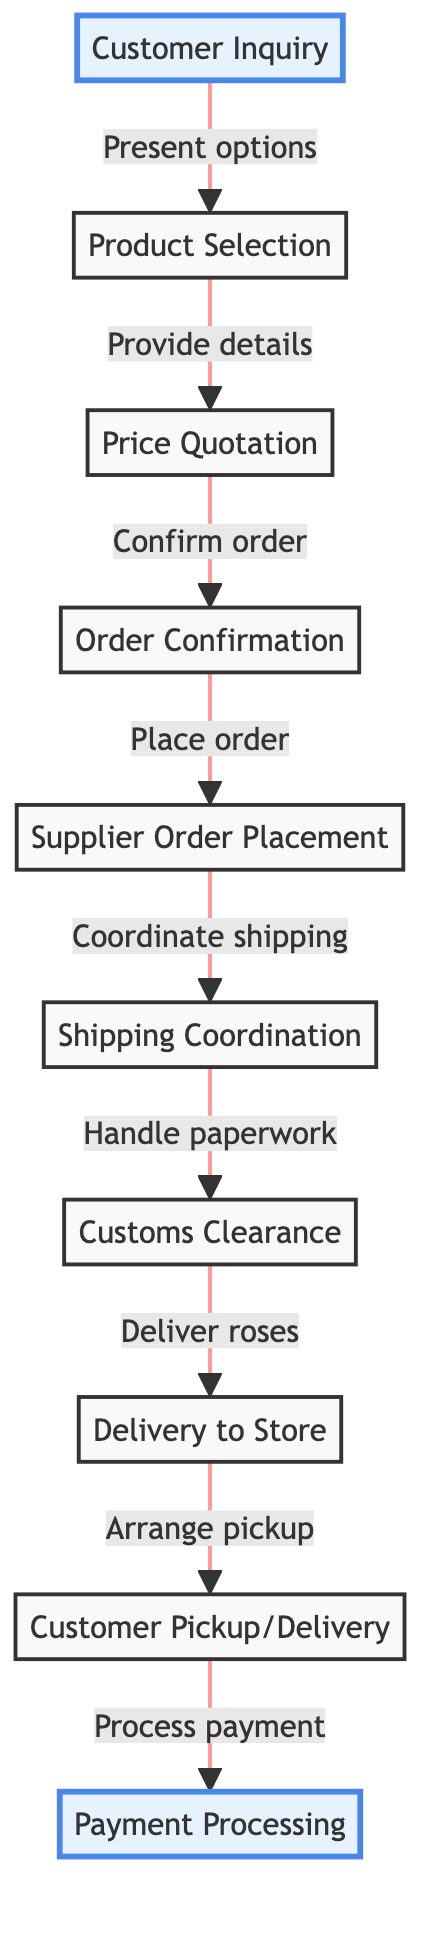What is the first step in the ordering process? The first step in the flow chart is "Customer Inquiry." This node is the starting point of the entire process, indicating that the customer contacts the florist to inquire about rose varieties and prices.
Answer: Customer Inquiry How many steps are there in the ordering process? By counting the nodes in the flow chart, there are a total of 10 steps, from "Customer Inquiry" to "Payment Processing." Each step represents a specific part of the process from start to finish.
Answer: 10 What action follows "Price Quotation"? The action that follows "Price Quotation" in the flow chart is "Order Confirmation." This indicates that after the florist provides pricing details, the customer confirms the order and provides delivery details.
Answer: Order Confirmation Which step involves handling paperwork and permits? The step involving handling paperwork and permits is "Customs Clearance." This step is essential to ensure that all necessary paperwork is completed for the importation of the roses.
Answer: Customs Clearance What are the last two steps in the order process? The last two steps in the order process are "Customer Pickup/Delivery" and "Payment Processing." These steps occur after the roses are delivered to the florist's shop and the customer either picks them up or receives them through delivery arrangements.
Answer: Customer Pickup/Delivery and Payment Processing Which step requires coordination with the shipping company? The step requiring coordination with the shipping company is "Shipping Coordination." This step follows the order placement and indicates the florist is arranging the transportation of the imported roses.
Answer: Shipping Coordination What is the relationship between "Order Confirmation" and "Supplier Order Placement"? The relationship is that "Order Confirmation" leads to "Supplier Order Placement." Once the customer confirms the order, the florist then places an order with the rose supplier overseas.
Answer: Order Confirmation leads to Supplier Order Placement How many connections are there from "Delivery to Store"? There is 1 connection from "Delivery to Store" leading to "Customer Pickup/Delivery." This indicates that the delivery to the shop is a direct precursor to the customer receiving their roses.
Answer: 1 